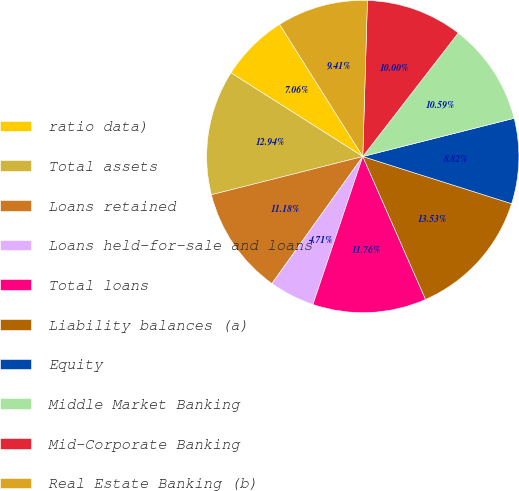<chart> <loc_0><loc_0><loc_500><loc_500><pie_chart><fcel>ratio data)<fcel>Total assets<fcel>Loans retained<fcel>Loans held-for-sale and loans<fcel>Total loans<fcel>Liability balances (a)<fcel>Equity<fcel>Middle Market Banking<fcel>Mid-Corporate Banking<fcel>Real Estate Banking (b)<nl><fcel>7.06%<fcel>12.94%<fcel>11.18%<fcel>4.71%<fcel>11.76%<fcel>13.53%<fcel>8.82%<fcel>10.59%<fcel>10.0%<fcel>9.41%<nl></chart> 